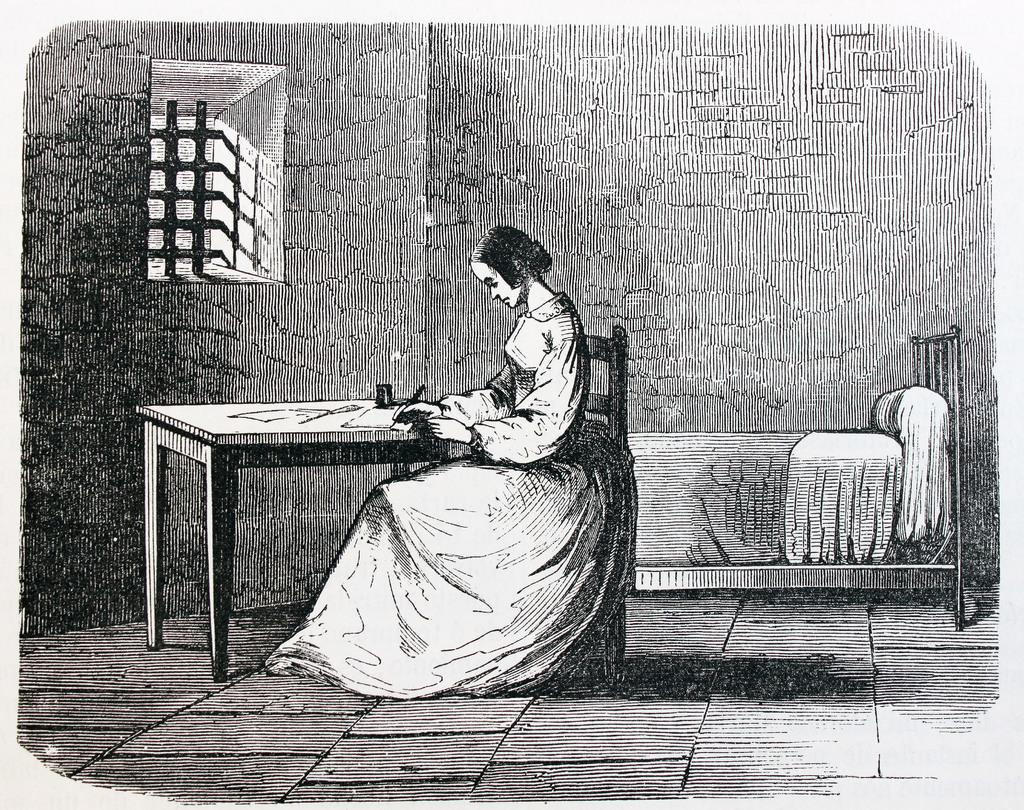What is the person in the image doing? The person is sitting on a chair in the image. What is the person holding? The person is holding something, but we cannot determine what it is from the image. What type of furniture is present in the image? There is a chair and a bed in the image. What is the background of the image? There is a wall and a window in the image. What is on the table in the image? There are objects on a table in the image. What is the color scheme of the image? The image is in black and white. What type of prose is being read by the person in the image? There is no indication in the image that the person is reading any prose. How many letters are visible on the wall in the image? There are no letters visible on the wall in the image. What type of rabbits can be seen playing on the bed in the image? There are no rabbits present in the image. 